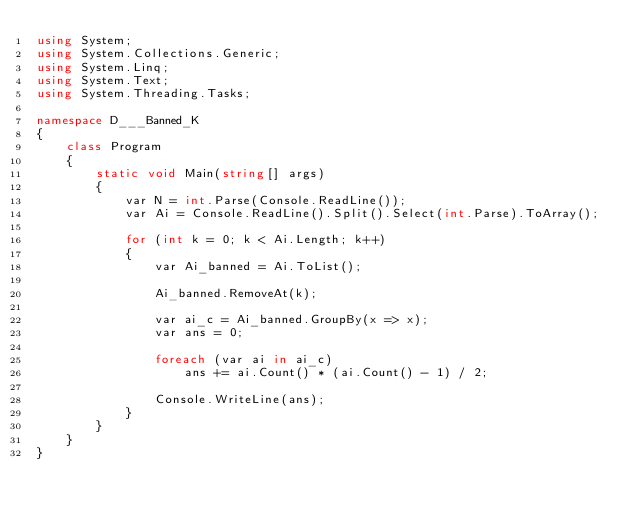<code> <loc_0><loc_0><loc_500><loc_500><_C#_>using System;
using System.Collections.Generic;
using System.Linq;
using System.Text;
using System.Threading.Tasks;

namespace D___Banned_K
{
    class Program
    {
        static void Main(string[] args)
        {
            var N = int.Parse(Console.ReadLine());
            var Ai = Console.ReadLine().Split().Select(int.Parse).ToArray();

            for (int k = 0; k < Ai.Length; k++)
            {
                var Ai_banned = Ai.ToList();

                Ai_banned.RemoveAt(k);

                var ai_c = Ai_banned.GroupBy(x => x);
                var ans = 0;

                foreach (var ai in ai_c)
                    ans += ai.Count() * (ai.Count() - 1) / 2;

                Console.WriteLine(ans);
            }
        }
    }
}
</code> 